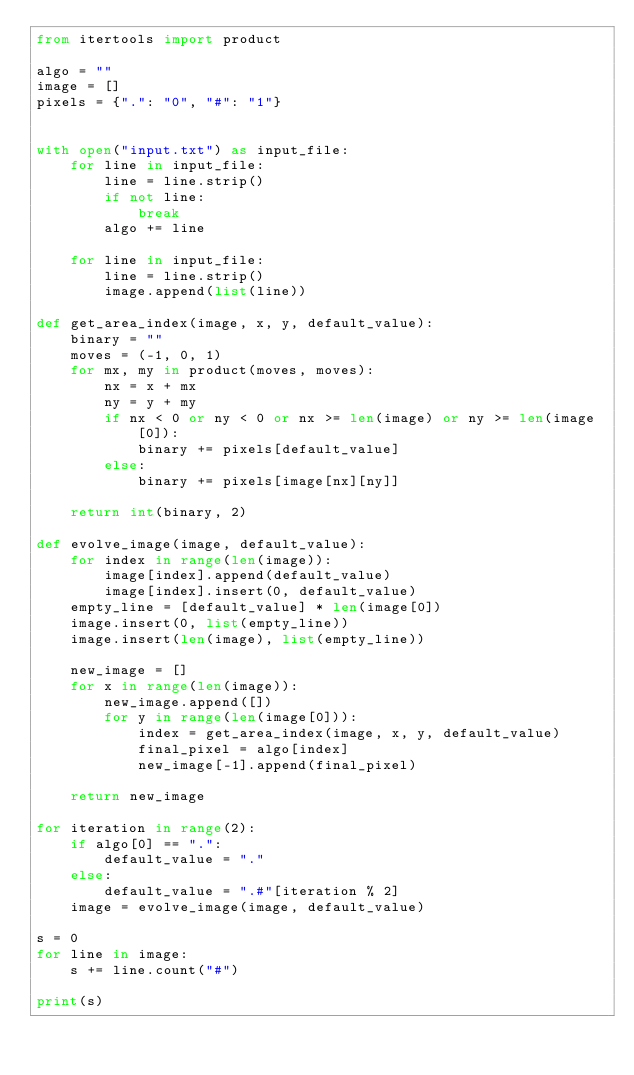Convert code to text. <code><loc_0><loc_0><loc_500><loc_500><_Python_>from itertools import product

algo = ""
image = []
pixels = {".": "0", "#": "1"}


with open("input.txt") as input_file:
    for line in input_file:
        line = line.strip()
        if not line:
            break
        algo += line
    
    for line in input_file:
        line = line.strip()
        image.append(list(line))

def get_area_index(image, x, y, default_value):
    binary = ""
    moves = (-1, 0, 1)
    for mx, my in product(moves, moves):
        nx = x + mx
        ny = y + my
        if nx < 0 or ny < 0 or nx >= len(image) or ny >= len(image[0]):
            binary += pixels[default_value]
        else:
            binary += pixels[image[nx][ny]]

    return int(binary, 2)

def evolve_image(image, default_value):
    for index in range(len(image)):
        image[index].append(default_value)
        image[index].insert(0, default_value)
    empty_line = [default_value] * len(image[0])
    image.insert(0, list(empty_line))
    image.insert(len(image), list(empty_line))

    new_image = []
    for x in range(len(image)):
        new_image.append([])
        for y in range(len(image[0])):
            index = get_area_index(image, x, y, default_value)
            final_pixel = algo[index]
            new_image[-1].append(final_pixel)
    
    return new_image

for iteration in range(2):
    if algo[0] == ".":
        default_value = "."
    else:
        default_value = ".#"[iteration % 2]
    image = evolve_image(image, default_value)

s = 0
for line in image:
    s += line.count("#")

print(s)
</code> 